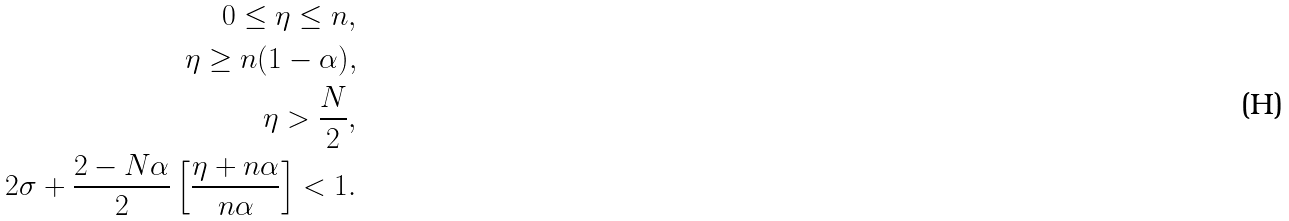<formula> <loc_0><loc_0><loc_500><loc_500>0 \leq \eta \leq n , \\ \eta \geq n ( 1 - \alpha ) , \\ \eta > \frac { N } { 2 } , \\ 2 \sigma + \frac { 2 - N \alpha } { 2 } \left [ \frac { \eta + n \alpha } { n \alpha } \right ] < 1 .</formula> 